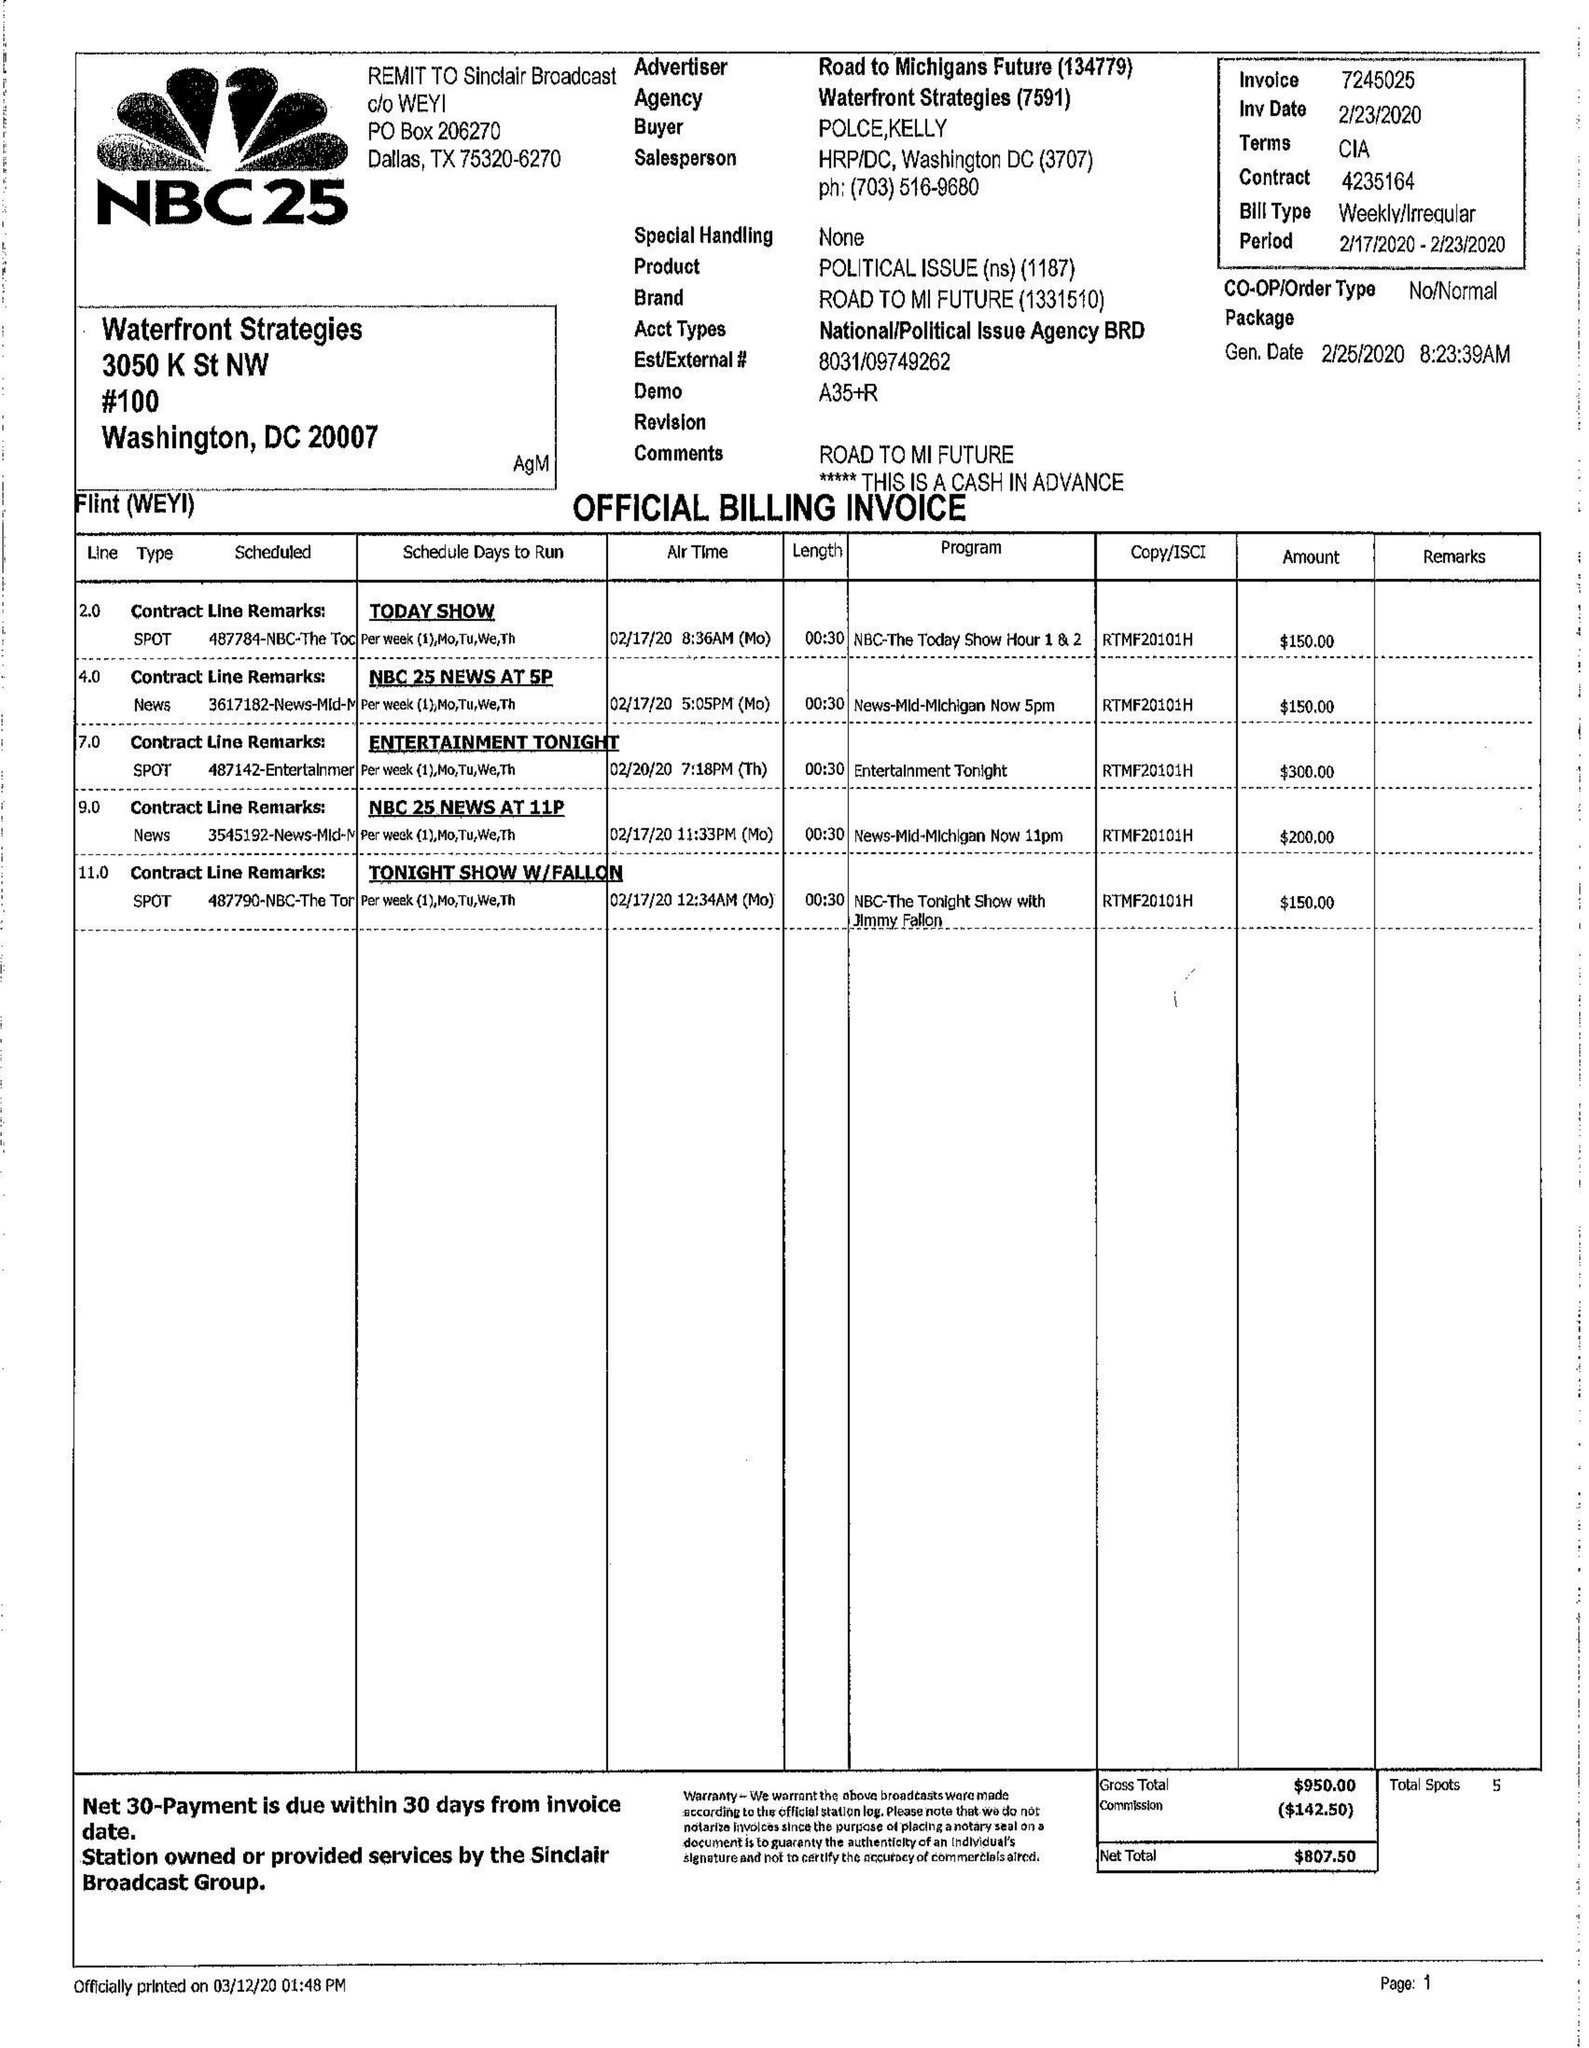What is the value for the gross_amount?
Answer the question using a single word or phrase. 2060.00 